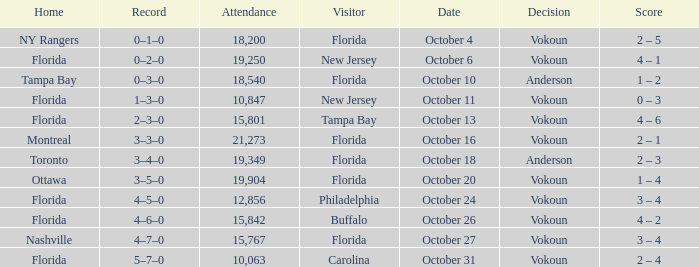Which team was home on October 13? Florida. 